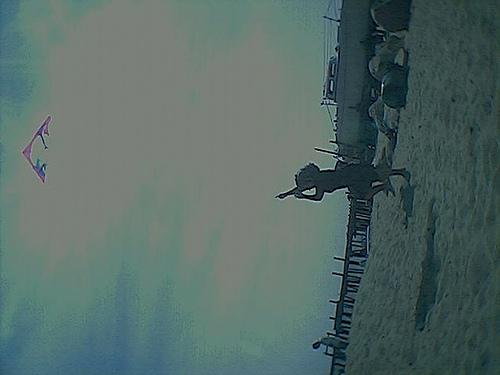Is this an Olympic sport?
Write a very short answer. No. Is the picture clear?
Keep it brief. No. Is the kid flying a kite?
Keep it brief. Yes. How many kites are on air?
Keep it brief. 1. Is this sand?
Quick response, please. Yes. 